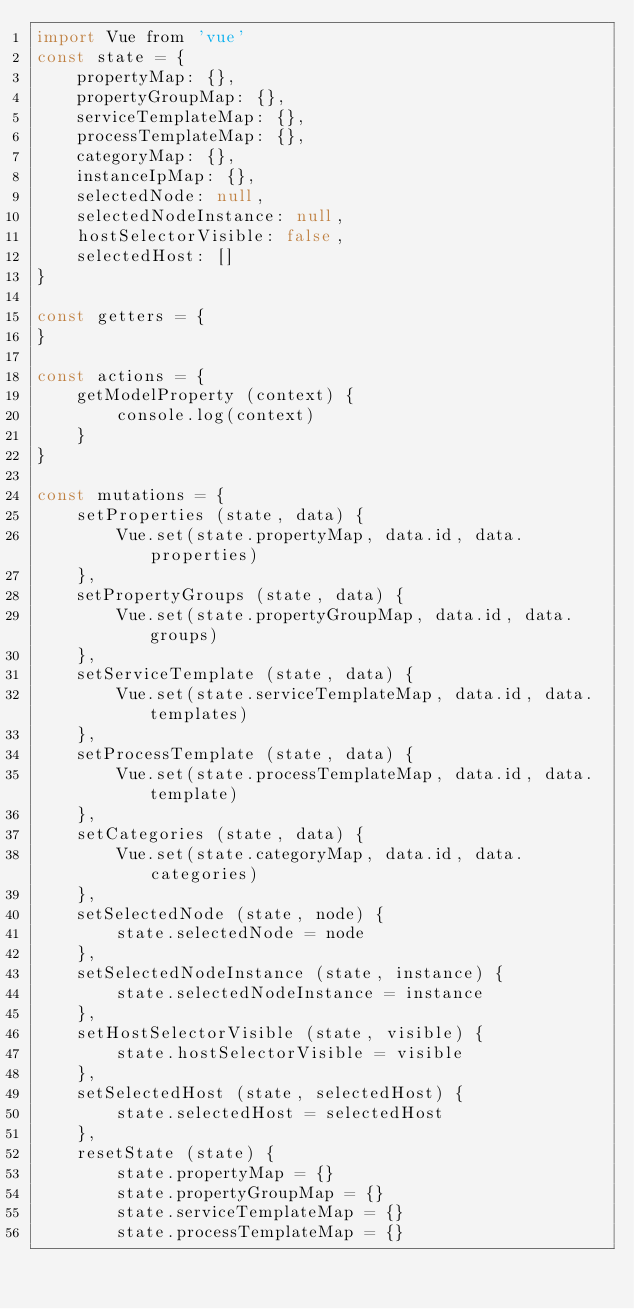<code> <loc_0><loc_0><loc_500><loc_500><_JavaScript_>import Vue from 'vue'
const state = {
    propertyMap: {},
    propertyGroupMap: {},
    serviceTemplateMap: {},
    processTemplateMap: {},
    categoryMap: {},
    instanceIpMap: {},
    selectedNode: null,
    selectedNodeInstance: null,
    hostSelectorVisible: false,
    selectedHost: []
}

const getters = {
}

const actions = {
    getModelProperty (context) {
        console.log(context)
    }
}

const mutations = {
    setProperties (state, data) {
        Vue.set(state.propertyMap, data.id, data.properties)
    },
    setPropertyGroups (state, data) {
        Vue.set(state.propertyGroupMap, data.id, data.groups)
    },
    setServiceTemplate (state, data) {
        Vue.set(state.serviceTemplateMap, data.id, data.templates)
    },
    setProcessTemplate (state, data) {
        Vue.set(state.processTemplateMap, data.id, data.template)
    },
    setCategories (state, data) {
        Vue.set(state.categoryMap, data.id, data.categories)
    },
    setSelectedNode (state, node) {
        state.selectedNode = node
    },
    setSelectedNodeInstance (state, instance) {
        state.selectedNodeInstance = instance
    },
    setHostSelectorVisible (state, visible) {
        state.hostSelectorVisible = visible
    },
    setSelectedHost (state, selectedHost) {
        state.selectedHost = selectedHost
    },
    resetState (state) {
        state.propertyMap = {}
        state.propertyGroupMap = {}
        state.serviceTemplateMap = {}
        state.processTemplateMap = {}</code> 